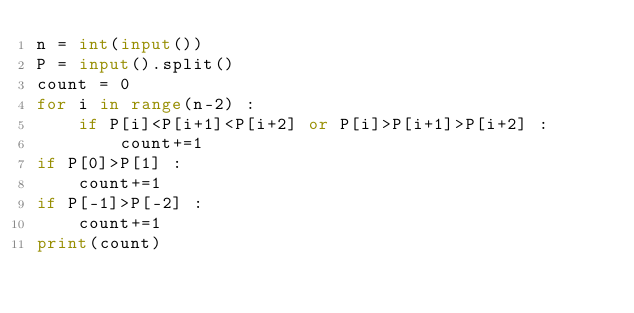Convert code to text. <code><loc_0><loc_0><loc_500><loc_500><_Python_>n = int(input())
P = input().split()
count = 0
for i in range(n-2) :
    if P[i]<P[i+1]<P[i+2] or P[i]>P[i+1]>P[i+2] :
        count+=1
if P[0]>P[1] :
    count+=1
if P[-1]>P[-2] :
    count+=1
print(count)</code> 